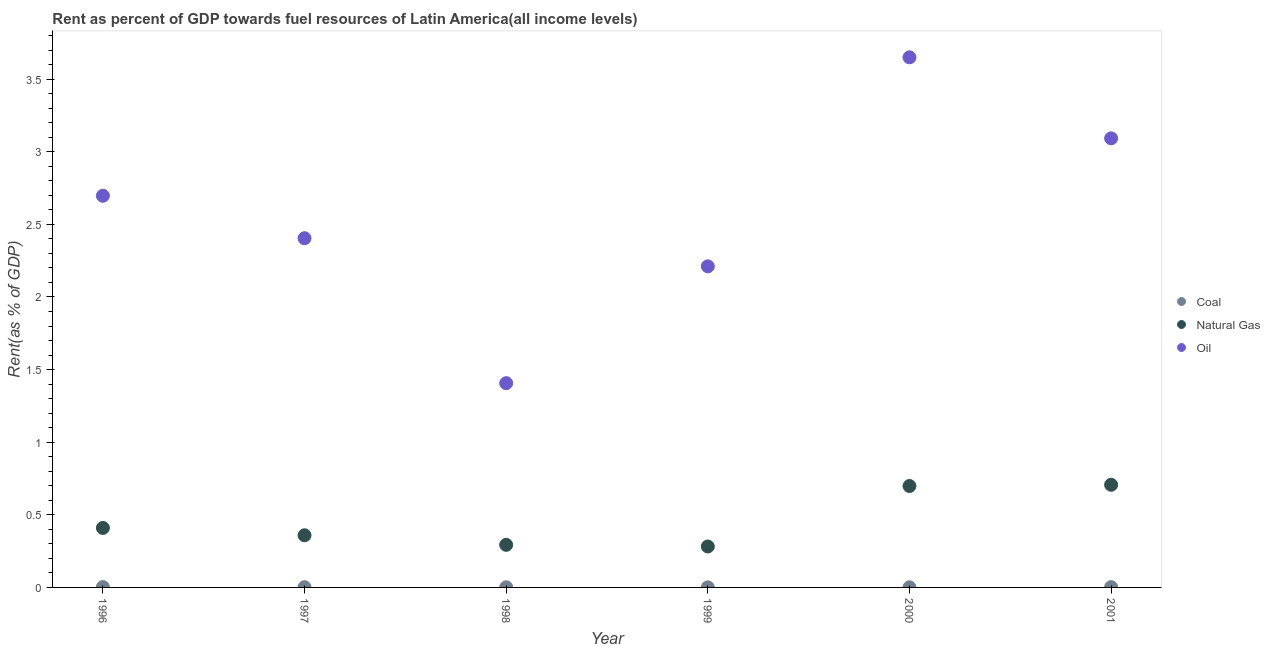What is the rent towards natural gas in 1998?
Offer a terse response. 0.29. Across all years, what is the maximum rent towards oil?
Give a very brief answer. 3.65. Across all years, what is the minimum rent towards coal?
Provide a succinct answer. 0. In which year was the rent towards oil maximum?
Provide a succinct answer. 2000. What is the total rent towards coal in the graph?
Your answer should be very brief. 0.01. What is the difference between the rent towards natural gas in 1998 and that in 2000?
Give a very brief answer. -0.41. What is the difference between the rent towards coal in 1997 and the rent towards natural gas in 2001?
Provide a short and direct response. -0.71. What is the average rent towards coal per year?
Make the answer very short. 0. In the year 2000, what is the difference between the rent towards coal and rent towards oil?
Ensure brevity in your answer.  -3.65. In how many years, is the rent towards oil greater than 2.5 %?
Provide a succinct answer. 3. What is the ratio of the rent towards coal in 1996 to that in 1999?
Your response must be concise. 3.99. Is the rent towards natural gas in 1999 less than that in 2000?
Your answer should be compact. Yes. What is the difference between the highest and the second highest rent towards oil?
Ensure brevity in your answer.  0.56. What is the difference between the highest and the lowest rent towards coal?
Keep it short and to the point. 0. In how many years, is the rent towards natural gas greater than the average rent towards natural gas taken over all years?
Provide a short and direct response. 2. Is the sum of the rent towards oil in 1998 and 2000 greater than the maximum rent towards coal across all years?
Keep it short and to the point. Yes. Does the rent towards coal monotonically increase over the years?
Offer a very short reply. No. Is the rent towards oil strictly less than the rent towards coal over the years?
Your response must be concise. No. How many dotlines are there?
Your response must be concise. 3. How many years are there in the graph?
Your answer should be compact. 6. Are the values on the major ticks of Y-axis written in scientific E-notation?
Offer a terse response. No. Does the graph contain any zero values?
Your response must be concise. No. How many legend labels are there?
Your answer should be very brief. 3. What is the title of the graph?
Your response must be concise. Rent as percent of GDP towards fuel resources of Latin America(all income levels). Does "Total employers" appear as one of the legend labels in the graph?
Ensure brevity in your answer.  No. What is the label or title of the Y-axis?
Offer a very short reply. Rent(as % of GDP). What is the Rent(as % of GDP) in Coal in 1996?
Make the answer very short. 0. What is the Rent(as % of GDP) of Natural Gas in 1996?
Provide a short and direct response. 0.41. What is the Rent(as % of GDP) in Oil in 1996?
Give a very brief answer. 2.7. What is the Rent(as % of GDP) of Coal in 1997?
Make the answer very short. 0. What is the Rent(as % of GDP) of Natural Gas in 1997?
Give a very brief answer. 0.36. What is the Rent(as % of GDP) in Oil in 1997?
Your response must be concise. 2.4. What is the Rent(as % of GDP) of Coal in 1998?
Offer a very short reply. 0. What is the Rent(as % of GDP) of Natural Gas in 1998?
Ensure brevity in your answer.  0.29. What is the Rent(as % of GDP) in Oil in 1998?
Make the answer very short. 1.41. What is the Rent(as % of GDP) in Coal in 1999?
Provide a succinct answer. 0. What is the Rent(as % of GDP) of Natural Gas in 1999?
Keep it short and to the point. 0.28. What is the Rent(as % of GDP) of Oil in 1999?
Provide a short and direct response. 2.21. What is the Rent(as % of GDP) of Coal in 2000?
Make the answer very short. 0. What is the Rent(as % of GDP) in Natural Gas in 2000?
Provide a succinct answer. 0.7. What is the Rent(as % of GDP) in Oil in 2000?
Make the answer very short. 3.65. What is the Rent(as % of GDP) in Coal in 2001?
Your answer should be compact. 0. What is the Rent(as % of GDP) in Natural Gas in 2001?
Your answer should be very brief. 0.71. What is the Rent(as % of GDP) of Oil in 2001?
Offer a terse response. 3.09. Across all years, what is the maximum Rent(as % of GDP) in Coal?
Give a very brief answer. 0. Across all years, what is the maximum Rent(as % of GDP) of Natural Gas?
Provide a succinct answer. 0.71. Across all years, what is the maximum Rent(as % of GDP) in Oil?
Provide a short and direct response. 3.65. Across all years, what is the minimum Rent(as % of GDP) of Coal?
Your answer should be compact. 0. Across all years, what is the minimum Rent(as % of GDP) of Natural Gas?
Your answer should be compact. 0.28. Across all years, what is the minimum Rent(as % of GDP) of Oil?
Your answer should be compact. 1.41. What is the total Rent(as % of GDP) of Coal in the graph?
Your answer should be compact. 0.01. What is the total Rent(as % of GDP) of Natural Gas in the graph?
Make the answer very short. 2.75. What is the total Rent(as % of GDP) of Oil in the graph?
Ensure brevity in your answer.  15.46. What is the difference between the Rent(as % of GDP) of Coal in 1996 and that in 1997?
Keep it short and to the point. 0. What is the difference between the Rent(as % of GDP) in Natural Gas in 1996 and that in 1997?
Provide a succinct answer. 0.05. What is the difference between the Rent(as % of GDP) in Oil in 1996 and that in 1997?
Offer a very short reply. 0.29. What is the difference between the Rent(as % of GDP) in Coal in 1996 and that in 1998?
Offer a very short reply. 0. What is the difference between the Rent(as % of GDP) in Natural Gas in 1996 and that in 1998?
Your response must be concise. 0.12. What is the difference between the Rent(as % of GDP) in Oil in 1996 and that in 1998?
Your response must be concise. 1.29. What is the difference between the Rent(as % of GDP) in Coal in 1996 and that in 1999?
Offer a terse response. 0. What is the difference between the Rent(as % of GDP) of Natural Gas in 1996 and that in 1999?
Provide a short and direct response. 0.13. What is the difference between the Rent(as % of GDP) in Oil in 1996 and that in 1999?
Your answer should be very brief. 0.49. What is the difference between the Rent(as % of GDP) of Coal in 1996 and that in 2000?
Ensure brevity in your answer.  0. What is the difference between the Rent(as % of GDP) of Natural Gas in 1996 and that in 2000?
Your answer should be compact. -0.29. What is the difference between the Rent(as % of GDP) in Oil in 1996 and that in 2000?
Your response must be concise. -0.95. What is the difference between the Rent(as % of GDP) of Natural Gas in 1996 and that in 2001?
Make the answer very short. -0.3. What is the difference between the Rent(as % of GDP) of Oil in 1996 and that in 2001?
Ensure brevity in your answer.  -0.4. What is the difference between the Rent(as % of GDP) of Coal in 1997 and that in 1998?
Your answer should be very brief. 0. What is the difference between the Rent(as % of GDP) in Natural Gas in 1997 and that in 1998?
Offer a terse response. 0.07. What is the difference between the Rent(as % of GDP) in Coal in 1997 and that in 1999?
Make the answer very short. 0. What is the difference between the Rent(as % of GDP) of Natural Gas in 1997 and that in 1999?
Your response must be concise. 0.08. What is the difference between the Rent(as % of GDP) in Oil in 1997 and that in 1999?
Provide a short and direct response. 0.19. What is the difference between the Rent(as % of GDP) in Coal in 1997 and that in 2000?
Give a very brief answer. 0. What is the difference between the Rent(as % of GDP) in Natural Gas in 1997 and that in 2000?
Make the answer very short. -0.34. What is the difference between the Rent(as % of GDP) in Oil in 1997 and that in 2000?
Your answer should be very brief. -1.25. What is the difference between the Rent(as % of GDP) in Coal in 1997 and that in 2001?
Your answer should be compact. -0. What is the difference between the Rent(as % of GDP) in Natural Gas in 1997 and that in 2001?
Your answer should be very brief. -0.35. What is the difference between the Rent(as % of GDP) of Oil in 1997 and that in 2001?
Offer a terse response. -0.69. What is the difference between the Rent(as % of GDP) in Natural Gas in 1998 and that in 1999?
Provide a succinct answer. 0.01. What is the difference between the Rent(as % of GDP) in Oil in 1998 and that in 1999?
Ensure brevity in your answer.  -0.8. What is the difference between the Rent(as % of GDP) of Natural Gas in 1998 and that in 2000?
Ensure brevity in your answer.  -0.41. What is the difference between the Rent(as % of GDP) of Oil in 1998 and that in 2000?
Offer a very short reply. -2.24. What is the difference between the Rent(as % of GDP) in Coal in 1998 and that in 2001?
Your answer should be very brief. -0. What is the difference between the Rent(as % of GDP) of Natural Gas in 1998 and that in 2001?
Provide a short and direct response. -0.41. What is the difference between the Rent(as % of GDP) of Oil in 1998 and that in 2001?
Provide a succinct answer. -1.69. What is the difference between the Rent(as % of GDP) in Coal in 1999 and that in 2000?
Provide a succinct answer. -0. What is the difference between the Rent(as % of GDP) in Natural Gas in 1999 and that in 2000?
Offer a terse response. -0.42. What is the difference between the Rent(as % of GDP) in Oil in 1999 and that in 2000?
Make the answer very short. -1.44. What is the difference between the Rent(as % of GDP) in Coal in 1999 and that in 2001?
Your answer should be compact. -0. What is the difference between the Rent(as % of GDP) in Natural Gas in 1999 and that in 2001?
Your response must be concise. -0.42. What is the difference between the Rent(as % of GDP) of Oil in 1999 and that in 2001?
Ensure brevity in your answer.  -0.88. What is the difference between the Rent(as % of GDP) in Coal in 2000 and that in 2001?
Provide a succinct answer. -0. What is the difference between the Rent(as % of GDP) in Natural Gas in 2000 and that in 2001?
Offer a terse response. -0.01. What is the difference between the Rent(as % of GDP) in Oil in 2000 and that in 2001?
Ensure brevity in your answer.  0.56. What is the difference between the Rent(as % of GDP) of Coal in 1996 and the Rent(as % of GDP) of Natural Gas in 1997?
Offer a terse response. -0.36. What is the difference between the Rent(as % of GDP) of Coal in 1996 and the Rent(as % of GDP) of Oil in 1997?
Provide a short and direct response. -2.4. What is the difference between the Rent(as % of GDP) in Natural Gas in 1996 and the Rent(as % of GDP) in Oil in 1997?
Your answer should be compact. -2. What is the difference between the Rent(as % of GDP) in Coal in 1996 and the Rent(as % of GDP) in Natural Gas in 1998?
Provide a succinct answer. -0.29. What is the difference between the Rent(as % of GDP) of Coal in 1996 and the Rent(as % of GDP) of Oil in 1998?
Give a very brief answer. -1.4. What is the difference between the Rent(as % of GDP) in Natural Gas in 1996 and the Rent(as % of GDP) in Oil in 1998?
Keep it short and to the point. -1. What is the difference between the Rent(as % of GDP) in Coal in 1996 and the Rent(as % of GDP) in Natural Gas in 1999?
Ensure brevity in your answer.  -0.28. What is the difference between the Rent(as % of GDP) in Coal in 1996 and the Rent(as % of GDP) in Oil in 1999?
Provide a succinct answer. -2.21. What is the difference between the Rent(as % of GDP) of Natural Gas in 1996 and the Rent(as % of GDP) of Oil in 1999?
Give a very brief answer. -1.8. What is the difference between the Rent(as % of GDP) of Coal in 1996 and the Rent(as % of GDP) of Natural Gas in 2000?
Offer a very short reply. -0.7. What is the difference between the Rent(as % of GDP) in Coal in 1996 and the Rent(as % of GDP) in Oil in 2000?
Offer a terse response. -3.65. What is the difference between the Rent(as % of GDP) in Natural Gas in 1996 and the Rent(as % of GDP) in Oil in 2000?
Make the answer very short. -3.24. What is the difference between the Rent(as % of GDP) in Coal in 1996 and the Rent(as % of GDP) in Natural Gas in 2001?
Offer a very short reply. -0.7. What is the difference between the Rent(as % of GDP) in Coal in 1996 and the Rent(as % of GDP) in Oil in 2001?
Offer a terse response. -3.09. What is the difference between the Rent(as % of GDP) of Natural Gas in 1996 and the Rent(as % of GDP) of Oil in 2001?
Give a very brief answer. -2.68. What is the difference between the Rent(as % of GDP) in Coal in 1997 and the Rent(as % of GDP) in Natural Gas in 1998?
Your answer should be very brief. -0.29. What is the difference between the Rent(as % of GDP) in Coal in 1997 and the Rent(as % of GDP) in Oil in 1998?
Keep it short and to the point. -1.4. What is the difference between the Rent(as % of GDP) in Natural Gas in 1997 and the Rent(as % of GDP) in Oil in 1998?
Offer a terse response. -1.05. What is the difference between the Rent(as % of GDP) in Coal in 1997 and the Rent(as % of GDP) in Natural Gas in 1999?
Ensure brevity in your answer.  -0.28. What is the difference between the Rent(as % of GDP) of Coal in 1997 and the Rent(as % of GDP) of Oil in 1999?
Make the answer very short. -2.21. What is the difference between the Rent(as % of GDP) in Natural Gas in 1997 and the Rent(as % of GDP) in Oil in 1999?
Provide a succinct answer. -1.85. What is the difference between the Rent(as % of GDP) in Coal in 1997 and the Rent(as % of GDP) in Natural Gas in 2000?
Offer a very short reply. -0.7. What is the difference between the Rent(as % of GDP) in Coal in 1997 and the Rent(as % of GDP) in Oil in 2000?
Give a very brief answer. -3.65. What is the difference between the Rent(as % of GDP) of Natural Gas in 1997 and the Rent(as % of GDP) of Oil in 2000?
Ensure brevity in your answer.  -3.29. What is the difference between the Rent(as % of GDP) in Coal in 1997 and the Rent(as % of GDP) in Natural Gas in 2001?
Keep it short and to the point. -0.71. What is the difference between the Rent(as % of GDP) of Coal in 1997 and the Rent(as % of GDP) of Oil in 2001?
Make the answer very short. -3.09. What is the difference between the Rent(as % of GDP) of Natural Gas in 1997 and the Rent(as % of GDP) of Oil in 2001?
Your answer should be very brief. -2.73. What is the difference between the Rent(as % of GDP) of Coal in 1998 and the Rent(as % of GDP) of Natural Gas in 1999?
Your answer should be very brief. -0.28. What is the difference between the Rent(as % of GDP) of Coal in 1998 and the Rent(as % of GDP) of Oil in 1999?
Your answer should be compact. -2.21. What is the difference between the Rent(as % of GDP) in Natural Gas in 1998 and the Rent(as % of GDP) in Oil in 1999?
Your response must be concise. -1.92. What is the difference between the Rent(as % of GDP) in Coal in 1998 and the Rent(as % of GDP) in Natural Gas in 2000?
Provide a short and direct response. -0.7. What is the difference between the Rent(as % of GDP) in Coal in 1998 and the Rent(as % of GDP) in Oil in 2000?
Your response must be concise. -3.65. What is the difference between the Rent(as % of GDP) in Natural Gas in 1998 and the Rent(as % of GDP) in Oil in 2000?
Provide a succinct answer. -3.36. What is the difference between the Rent(as % of GDP) of Coal in 1998 and the Rent(as % of GDP) of Natural Gas in 2001?
Make the answer very short. -0.71. What is the difference between the Rent(as % of GDP) in Coal in 1998 and the Rent(as % of GDP) in Oil in 2001?
Offer a very short reply. -3.09. What is the difference between the Rent(as % of GDP) in Natural Gas in 1998 and the Rent(as % of GDP) in Oil in 2001?
Offer a terse response. -2.8. What is the difference between the Rent(as % of GDP) of Coal in 1999 and the Rent(as % of GDP) of Natural Gas in 2000?
Offer a terse response. -0.7. What is the difference between the Rent(as % of GDP) of Coal in 1999 and the Rent(as % of GDP) of Oil in 2000?
Ensure brevity in your answer.  -3.65. What is the difference between the Rent(as % of GDP) in Natural Gas in 1999 and the Rent(as % of GDP) in Oil in 2000?
Your answer should be compact. -3.37. What is the difference between the Rent(as % of GDP) in Coal in 1999 and the Rent(as % of GDP) in Natural Gas in 2001?
Offer a terse response. -0.71. What is the difference between the Rent(as % of GDP) in Coal in 1999 and the Rent(as % of GDP) in Oil in 2001?
Provide a succinct answer. -3.09. What is the difference between the Rent(as % of GDP) in Natural Gas in 1999 and the Rent(as % of GDP) in Oil in 2001?
Your answer should be compact. -2.81. What is the difference between the Rent(as % of GDP) in Coal in 2000 and the Rent(as % of GDP) in Natural Gas in 2001?
Give a very brief answer. -0.71. What is the difference between the Rent(as % of GDP) in Coal in 2000 and the Rent(as % of GDP) in Oil in 2001?
Give a very brief answer. -3.09. What is the difference between the Rent(as % of GDP) in Natural Gas in 2000 and the Rent(as % of GDP) in Oil in 2001?
Your response must be concise. -2.39. What is the average Rent(as % of GDP) of Coal per year?
Keep it short and to the point. 0. What is the average Rent(as % of GDP) in Natural Gas per year?
Give a very brief answer. 0.46. What is the average Rent(as % of GDP) of Oil per year?
Provide a succinct answer. 2.58. In the year 1996, what is the difference between the Rent(as % of GDP) in Coal and Rent(as % of GDP) in Natural Gas?
Provide a succinct answer. -0.41. In the year 1996, what is the difference between the Rent(as % of GDP) of Coal and Rent(as % of GDP) of Oil?
Offer a terse response. -2.69. In the year 1996, what is the difference between the Rent(as % of GDP) in Natural Gas and Rent(as % of GDP) in Oil?
Your answer should be very brief. -2.29. In the year 1997, what is the difference between the Rent(as % of GDP) in Coal and Rent(as % of GDP) in Natural Gas?
Your response must be concise. -0.36. In the year 1997, what is the difference between the Rent(as % of GDP) of Coal and Rent(as % of GDP) of Oil?
Offer a very short reply. -2.4. In the year 1997, what is the difference between the Rent(as % of GDP) in Natural Gas and Rent(as % of GDP) in Oil?
Offer a very short reply. -2.05. In the year 1998, what is the difference between the Rent(as % of GDP) in Coal and Rent(as % of GDP) in Natural Gas?
Your answer should be compact. -0.29. In the year 1998, what is the difference between the Rent(as % of GDP) in Coal and Rent(as % of GDP) in Oil?
Ensure brevity in your answer.  -1.41. In the year 1998, what is the difference between the Rent(as % of GDP) in Natural Gas and Rent(as % of GDP) in Oil?
Your answer should be very brief. -1.11. In the year 1999, what is the difference between the Rent(as % of GDP) in Coal and Rent(as % of GDP) in Natural Gas?
Make the answer very short. -0.28. In the year 1999, what is the difference between the Rent(as % of GDP) of Coal and Rent(as % of GDP) of Oil?
Keep it short and to the point. -2.21. In the year 1999, what is the difference between the Rent(as % of GDP) of Natural Gas and Rent(as % of GDP) of Oil?
Offer a terse response. -1.93. In the year 2000, what is the difference between the Rent(as % of GDP) in Coal and Rent(as % of GDP) in Natural Gas?
Your answer should be compact. -0.7. In the year 2000, what is the difference between the Rent(as % of GDP) in Coal and Rent(as % of GDP) in Oil?
Your response must be concise. -3.65. In the year 2000, what is the difference between the Rent(as % of GDP) of Natural Gas and Rent(as % of GDP) of Oil?
Provide a short and direct response. -2.95. In the year 2001, what is the difference between the Rent(as % of GDP) in Coal and Rent(as % of GDP) in Natural Gas?
Your answer should be very brief. -0.7. In the year 2001, what is the difference between the Rent(as % of GDP) of Coal and Rent(as % of GDP) of Oil?
Your response must be concise. -3.09. In the year 2001, what is the difference between the Rent(as % of GDP) of Natural Gas and Rent(as % of GDP) of Oil?
Make the answer very short. -2.39. What is the ratio of the Rent(as % of GDP) in Coal in 1996 to that in 1997?
Make the answer very short. 1.37. What is the ratio of the Rent(as % of GDP) of Natural Gas in 1996 to that in 1997?
Your response must be concise. 1.14. What is the ratio of the Rent(as % of GDP) of Oil in 1996 to that in 1997?
Provide a short and direct response. 1.12. What is the ratio of the Rent(as % of GDP) in Coal in 1996 to that in 1998?
Offer a terse response. 2.73. What is the ratio of the Rent(as % of GDP) of Natural Gas in 1996 to that in 1998?
Your answer should be compact. 1.4. What is the ratio of the Rent(as % of GDP) of Oil in 1996 to that in 1998?
Provide a succinct answer. 1.92. What is the ratio of the Rent(as % of GDP) of Coal in 1996 to that in 1999?
Provide a succinct answer. 3.99. What is the ratio of the Rent(as % of GDP) in Natural Gas in 1996 to that in 1999?
Your answer should be compact. 1.45. What is the ratio of the Rent(as % of GDP) in Oil in 1996 to that in 1999?
Ensure brevity in your answer.  1.22. What is the ratio of the Rent(as % of GDP) in Coal in 1996 to that in 2000?
Your answer should be very brief. 2.69. What is the ratio of the Rent(as % of GDP) in Natural Gas in 1996 to that in 2000?
Offer a very short reply. 0.59. What is the ratio of the Rent(as % of GDP) of Oil in 1996 to that in 2000?
Give a very brief answer. 0.74. What is the ratio of the Rent(as % of GDP) in Coal in 1996 to that in 2001?
Ensure brevity in your answer.  1.23. What is the ratio of the Rent(as % of GDP) of Natural Gas in 1996 to that in 2001?
Offer a terse response. 0.58. What is the ratio of the Rent(as % of GDP) in Oil in 1996 to that in 2001?
Offer a terse response. 0.87. What is the ratio of the Rent(as % of GDP) of Coal in 1997 to that in 1998?
Make the answer very short. 1.99. What is the ratio of the Rent(as % of GDP) of Natural Gas in 1997 to that in 1998?
Offer a terse response. 1.23. What is the ratio of the Rent(as % of GDP) of Oil in 1997 to that in 1998?
Provide a succinct answer. 1.71. What is the ratio of the Rent(as % of GDP) in Coal in 1997 to that in 1999?
Your response must be concise. 2.91. What is the ratio of the Rent(as % of GDP) in Natural Gas in 1997 to that in 1999?
Provide a succinct answer. 1.27. What is the ratio of the Rent(as % of GDP) in Oil in 1997 to that in 1999?
Provide a short and direct response. 1.09. What is the ratio of the Rent(as % of GDP) of Coal in 1997 to that in 2000?
Offer a very short reply. 1.96. What is the ratio of the Rent(as % of GDP) of Natural Gas in 1997 to that in 2000?
Offer a very short reply. 0.51. What is the ratio of the Rent(as % of GDP) in Oil in 1997 to that in 2000?
Make the answer very short. 0.66. What is the ratio of the Rent(as % of GDP) in Coal in 1997 to that in 2001?
Offer a very short reply. 0.89. What is the ratio of the Rent(as % of GDP) of Natural Gas in 1997 to that in 2001?
Ensure brevity in your answer.  0.51. What is the ratio of the Rent(as % of GDP) in Oil in 1997 to that in 2001?
Keep it short and to the point. 0.78. What is the ratio of the Rent(as % of GDP) in Coal in 1998 to that in 1999?
Ensure brevity in your answer.  1.46. What is the ratio of the Rent(as % of GDP) in Natural Gas in 1998 to that in 1999?
Your response must be concise. 1.04. What is the ratio of the Rent(as % of GDP) of Oil in 1998 to that in 1999?
Keep it short and to the point. 0.64. What is the ratio of the Rent(as % of GDP) in Coal in 1998 to that in 2000?
Your answer should be very brief. 0.99. What is the ratio of the Rent(as % of GDP) in Natural Gas in 1998 to that in 2000?
Keep it short and to the point. 0.42. What is the ratio of the Rent(as % of GDP) of Oil in 1998 to that in 2000?
Provide a short and direct response. 0.39. What is the ratio of the Rent(as % of GDP) in Coal in 1998 to that in 2001?
Give a very brief answer. 0.45. What is the ratio of the Rent(as % of GDP) of Natural Gas in 1998 to that in 2001?
Provide a succinct answer. 0.41. What is the ratio of the Rent(as % of GDP) of Oil in 1998 to that in 2001?
Make the answer very short. 0.45. What is the ratio of the Rent(as % of GDP) in Coal in 1999 to that in 2000?
Make the answer very short. 0.68. What is the ratio of the Rent(as % of GDP) of Natural Gas in 1999 to that in 2000?
Ensure brevity in your answer.  0.4. What is the ratio of the Rent(as % of GDP) of Oil in 1999 to that in 2000?
Provide a short and direct response. 0.61. What is the ratio of the Rent(as % of GDP) in Coal in 1999 to that in 2001?
Your answer should be compact. 0.31. What is the ratio of the Rent(as % of GDP) in Natural Gas in 1999 to that in 2001?
Make the answer very short. 0.4. What is the ratio of the Rent(as % of GDP) in Oil in 1999 to that in 2001?
Keep it short and to the point. 0.71. What is the ratio of the Rent(as % of GDP) of Coal in 2000 to that in 2001?
Offer a very short reply. 0.46. What is the ratio of the Rent(as % of GDP) of Natural Gas in 2000 to that in 2001?
Your answer should be very brief. 0.99. What is the ratio of the Rent(as % of GDP) in Oil in 2000 to that in 2001?
Provide a short and direct response. 1.18. What is the difference between the highest and the second highest Rent(as % of GDP) of Natural Gas?
Offer a very short reply. 0.01. What is the difference between the highest and the second highest Rent(as % of GDP) in Oil?
Provide a short and direct response. 0.56. What is the difference between the highest and the lowest Rent(as % of GDP) of Coal?
Ensure brevity in your answer.  0. What is the difference between the highest and the lowest Rent(as % of GDP) in Natural Gas?
Provide a short and direct response. 0.42. What is the difference between the highest and the lowest Rent(as % of GDP) in Oil?
Ensure brevity in your answer.  2.24. 